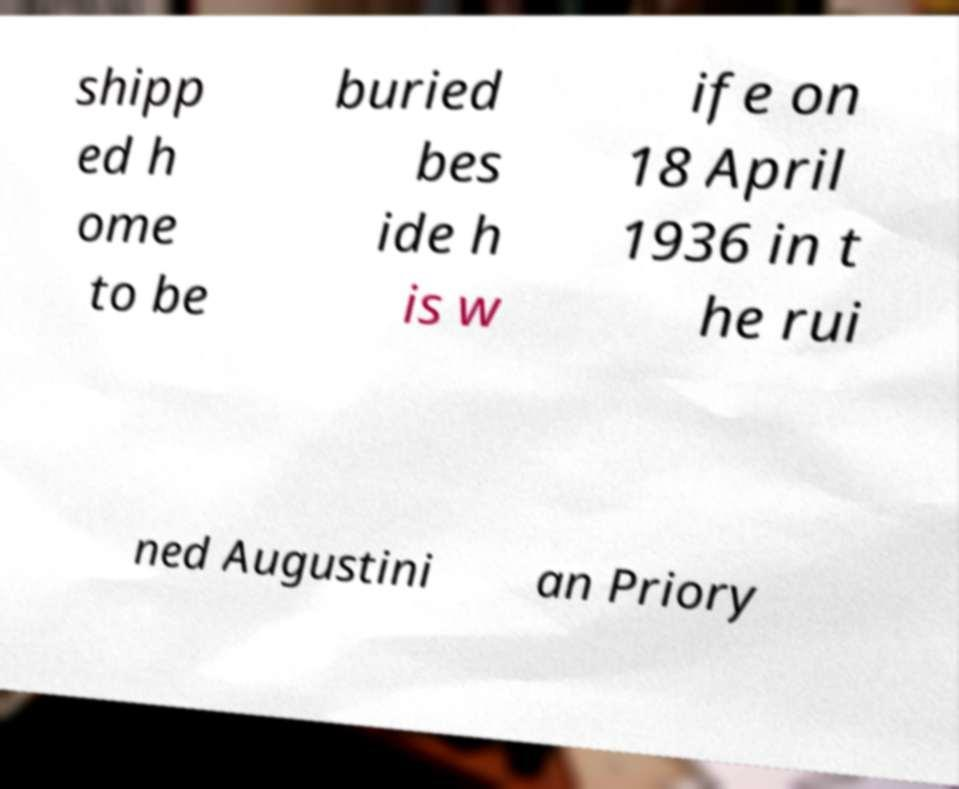Can you accurately transcribe the text from the provided image for me? shipp ed h ome to be buried bes ide h is w ife on 18 April 1936 in t he rui ned Augustini an Priory 